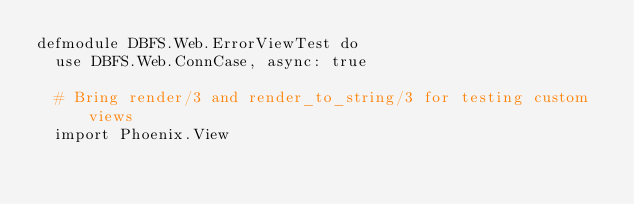Convert code to text. <code><loc_0><loc_0><loc_500><loc_500><_Elixir_>defmodule DBFS.Web.ErrorViewTest do
  use DBFS.Web.ConnCase, async: true

  # Bring render/3 and render_to_string/3 for testing custom views
  import Phoenix.View
</code> 